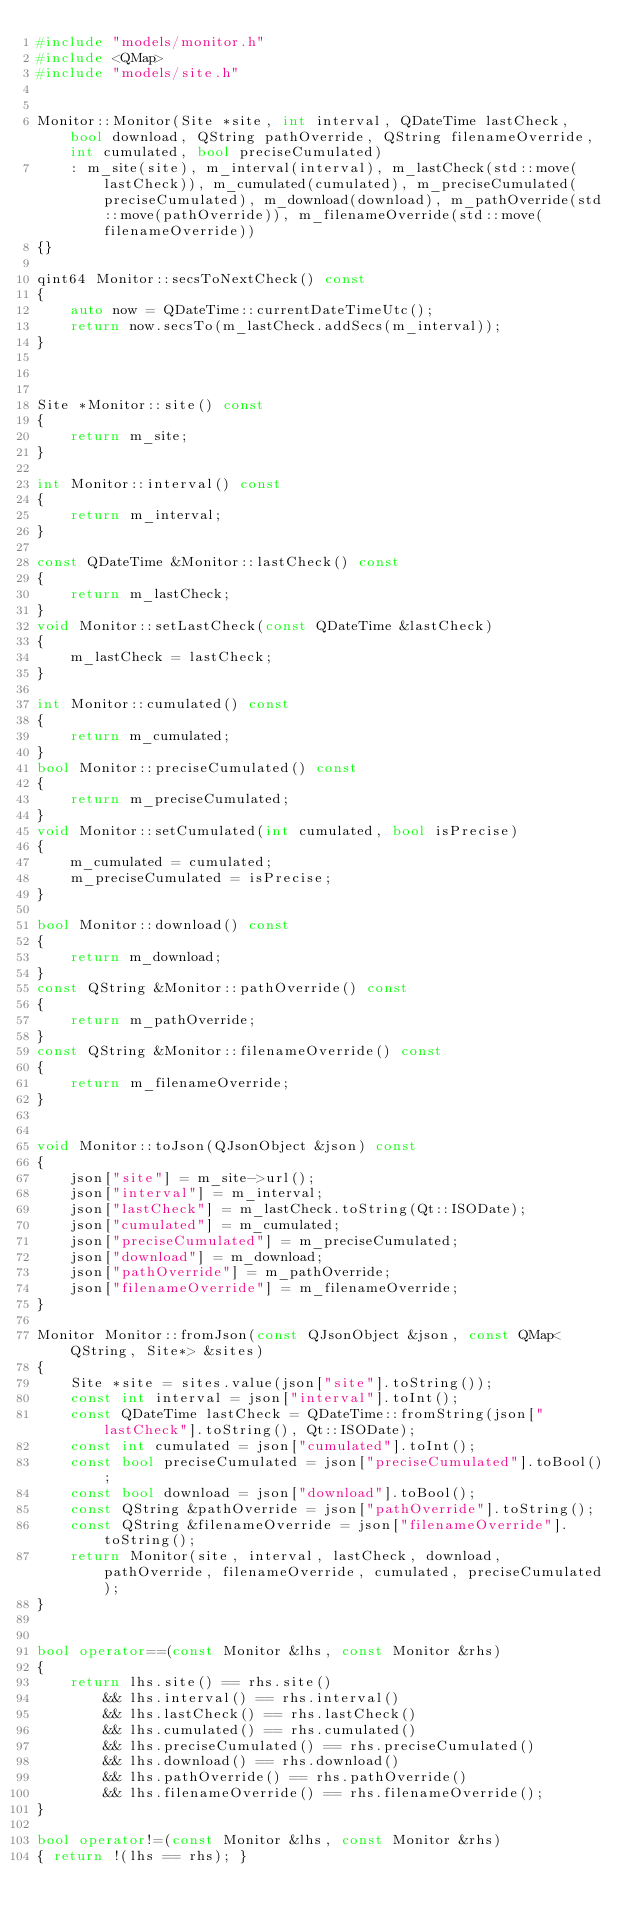Convert code to text. <code><loc_0><loc_0><loc_500><loc_500><_C++_>#include "models/monitor.h"
#include <QMap>
#include "models/site.h"


Monitor::Monitor(Site *site, int interval, QDateTime lastCheck, bool download, QString pathOverride, QString filenameOverride, int cumulated, bool preciseCumulated)
    : m_site(site), m_interval(interval), m_lastCheck(std::move(lastCheck)), m_cumulated(cumulated), m_preciseCumulated(preciseCumulated), m_download(download), m_pathOverride(std::move(pathOverride)), m_filenameOverride(std::move(filenameOverride))
{}

qint64 Monitor::secsToNextCheck() const
{
	auto now = QDateTime::currentDateTimeUtc();
	return now.secsTo(m_lastCheck.addSecs(m_interval));
}



Site *Monitor::site() const
{
	return m_site;
}

int Monitor::interval() const
{
	return m_interval;
}

const QDateTime &Monitor::lastCheck() const
{
	return m_lastCheck;
}
void Monitor::setLastCheck(const QDateTime &lastCheck)
{
	m_lastCheck = lastCheck;
}

int Monitor::cumulated() const
{
	return m_cumulated;
}
bool Monitor::preciseCumulated() const
{
	return m_preciseCumulated;
}
void Monitor::setCumulated(int cumulated, bool isPrecise)
{
	m_cumulated = cumulated;
	m_preciseCumulated = isPrecise;
}

bool Monitor::download() const
{
    return m_download;
}
const QString &Monitor::pathOverride() const
{
    return m_pathOverride;
}
const QString &Monitor::filenameOverride() const
{
    return m_filenameOverride;
}


void Monitor::toJson(QJsonObject &json) const
{
	json["site"] = m_site->url();
	json["interval"] = m_interval;
	json["lastCheck"] = m_lastCheck.toString(Qt::ISODate);
	json["cumulated"] = m_cumulated;
    json["preciseCumulated"] = m_preciseCumulated;
    json["download"] = m_download;
    json["pathOverride"] = m_pathOverride;
    json["filenameOverride"] = m_filenameOverride;
}

Monitor Monitor::fromJson(const QJsonObject &json, const QMap<QString, Site*> &sites)
{
	Site *site = sites.value(json["site"].toString());
	const int interval = json["interval"].toInt();
	const QDateTime lastCheck = QDateTime::fromString(json["lastCheck"].toString(), Qt::ISODate);
	const int cumulated = json["cumulated"].toInt();
	const bool preciseCumulated = json["preciseCumulated"].toBool();
    const bool download = json["download"].toBool();
    const QString &pathOverride = json["pathOverride"].toString();
    const QString &filenameOverride = json["filenameOverride"].toString();
    return Monitor(site, interval, lastCheck, download, pathOverride, filenameOverride, cumulated, preciseCumulated);
}


bool operator==(const Monitor &lhs, const Monitor &rhs)
{
	return lhs.site() == rhs.site()
		&& lhs.interval() == rhs.interval()
		&& lhs.lastCheck() == rhs.lastCheck()
		&& lhs.cumulated() == rhs.cumulated()
        && lhs.preciseCumulated() == rhs.preciseCumulated()
        && lhs.download() == rhs.download()
        && lhs.pathOverride() == rhs.pathOverride()
        && lhs.filenameOverride() == rhs.filenameOverride();
}

bool operator!=(const Monitor &lhs, const Monitor &rhs)
{ return !(lhs == rhs); }
</code> 